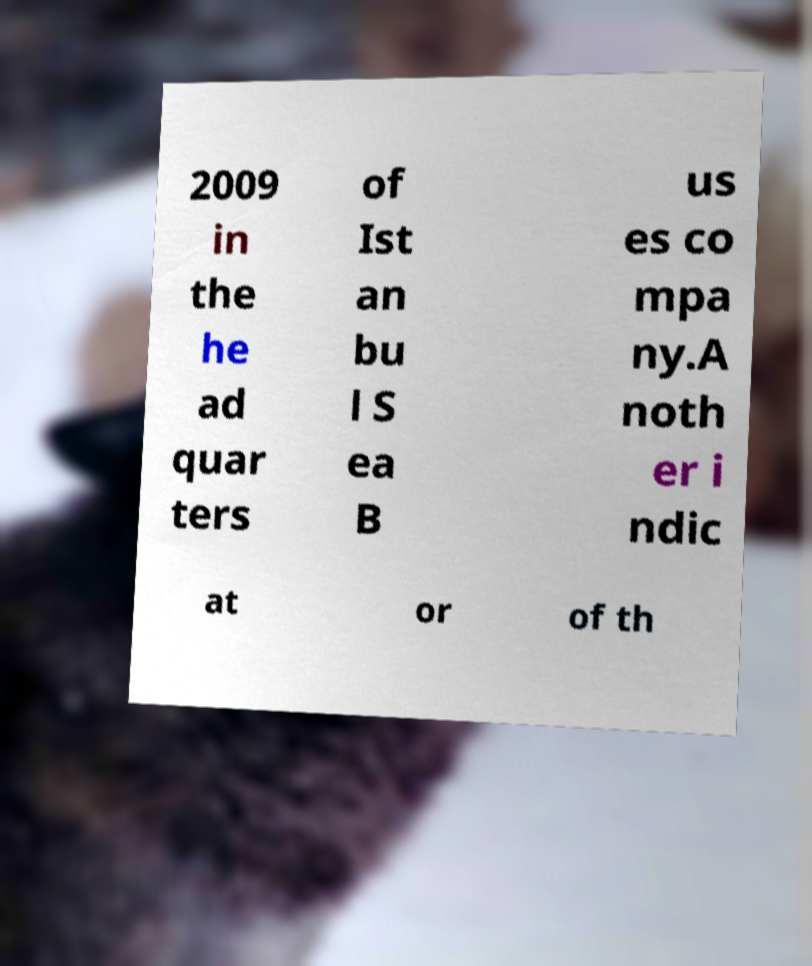There's text embedded in this image that I need extracted. Can you transcribe it verbatim? 2009 in the he ad quar ters of Ist an bu l S ea B us es co mpa ny.A noth er i ndic at or of th 